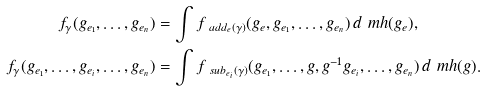<formula> <loc_0><loc_0><loc_500><loc_500>f _ { \gamma } ( g _ { e _ { 1 } } , \dots , g _ { e _ { n } } ) & = \int f _ { \ a d d _ { e } ( \gamma ) } ( g _ { e } , g _ { e _ { 1 } } , \dots , g _ { e _ { n } } ) \, d \ m h ( g _ { e } ) , \\ f _ { \gamma } ( g _ { e _ { 1 } } , \dots , g _ { e _ { i } } , \dots , g _ { e _ { n } } ) & = \int f _ { \ s u b _ { e _ { i } } ( \gamma ) } ( g _ { e _ { 1 } } , \dots , g , g ^ { - 1 } g _ { e _ { i } } , \dots , g _ { e _ { n } } ) \, d \ m h ( g ) .</formula> 